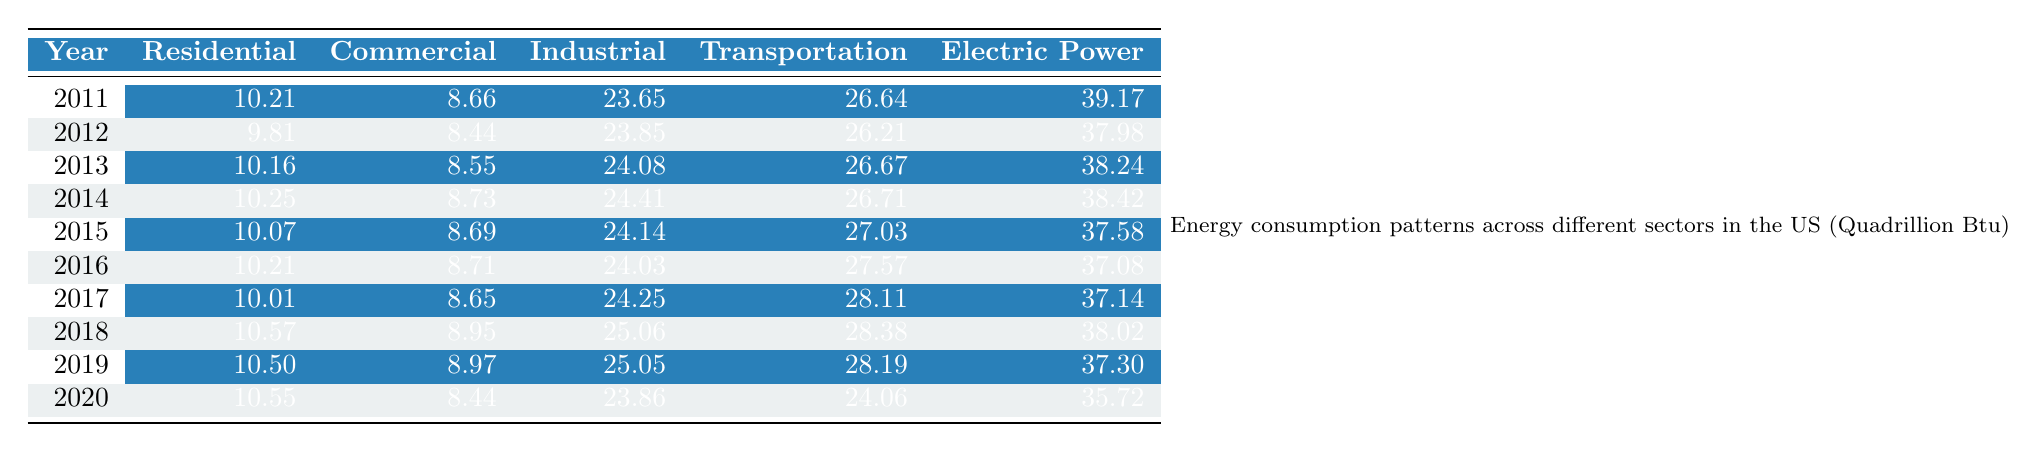What was the energy consumption in the Residential sector in 2011? In the table, the energy consumption for the Residential sector in the year 2011 is directly listed as 10.21 Quadrillion Btu.
Answer: 10.21 What was the total energy consumption across all sectors in 2019? To find the total energy consumption in 2019, add the values for all sectors: 10.50 (Residential) + 8.97 (Commercial) + 25.05 (Industrial) + 28.19 (Transportation) + 37.30 (Electric Power) = 110.01 Quadrillion Btu.
Answer: 110.01 What was the highest energy consumption recorded in the Industrial sector? The highest value in the Industrial sector is found by looking for the maximum among the listed values: 23.65 in 2011, 23.85 in 2012, 24.08 in 2013, 24.41 in 2014, 24.14 in 2015, 24.03 in 2016, 24.25 in 2017, 25.06 in 2018, 25.05 in 2019, and 23.86 in 2020. The maximum is 25.06 in 2018.
Answer: 25.06 Did the energy consumption in the Commercial sector increase from 2018 to 2020? Compare the values for the Commercial sector in 2018 (8.95) and 2020 (8.44). Since 8.44 is less than 8.95, the consumption decreased.
Answer: No What was the difference in energy consumption for the Residential sector between 2011 and 2020? Subtract the value for the Residential sector in 2020 (10.55) from the value in 2011 (10.21): 10.55 - 10.21 = 0.34 Quadrillion Btu.
Answer: 0.34 Which sector had the lowest energy consumption in 2012? In 2012, the values listed for each sector were: Residential (9.81), Commercial (8.44), Industrial (23.85), Transportation (26.21), and Electric Power (37.98). The lowest value is 8.44 in the Commercial sector.
Answer: Commercial What trend can be observed in the Transportation sector from 2011 to 2020? Looking at the data from 2011 (26.64) to 2020 (24.06), the values show a decrease each year except for a slight increase in 2015 and 2016. Thus, generally, the trend indicates a decline over the decade.
Answer: Decreasing trend What was the average energy consumption for the Electric Power sector over the decade? To find the average for the Electric Power sector, add up all values: 39.17 + 37.98 + 38.24 + 38.42 + 37.58 + 37.08 + 37.14 + 38.02 + 37.30 + 35.72 = 376.65 Quadrillion Btu. Divide by the number of years (10): 376.65 / 10 = 37.665.
Answer: 37.67 Was there any year where the energy consumption in the Residential sector was higher than in the Electric Power sector? Identify the years where Residential values are compared to Electric Power. Only in 2011 (10.21 vs 39.17) was this true; in 2012 (9.81 to 37.98), it is not true in following years. So no year had more.
Answer: No How much did energy consumption in the Industrial sector increase from 2011 to 2019? In 2011, the Industrial energy consumption was 23.65 Quadrillion Btu, and in 2019, it was 25.05. The increase is calculated by: 25.05 - 23.65 = 1.40 Quadrillion Btu.
Answer: 1.40 